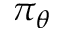<formula> <loc_0><loc_0><loc_500><loc_500>\pi _ { \theta }</formula> 